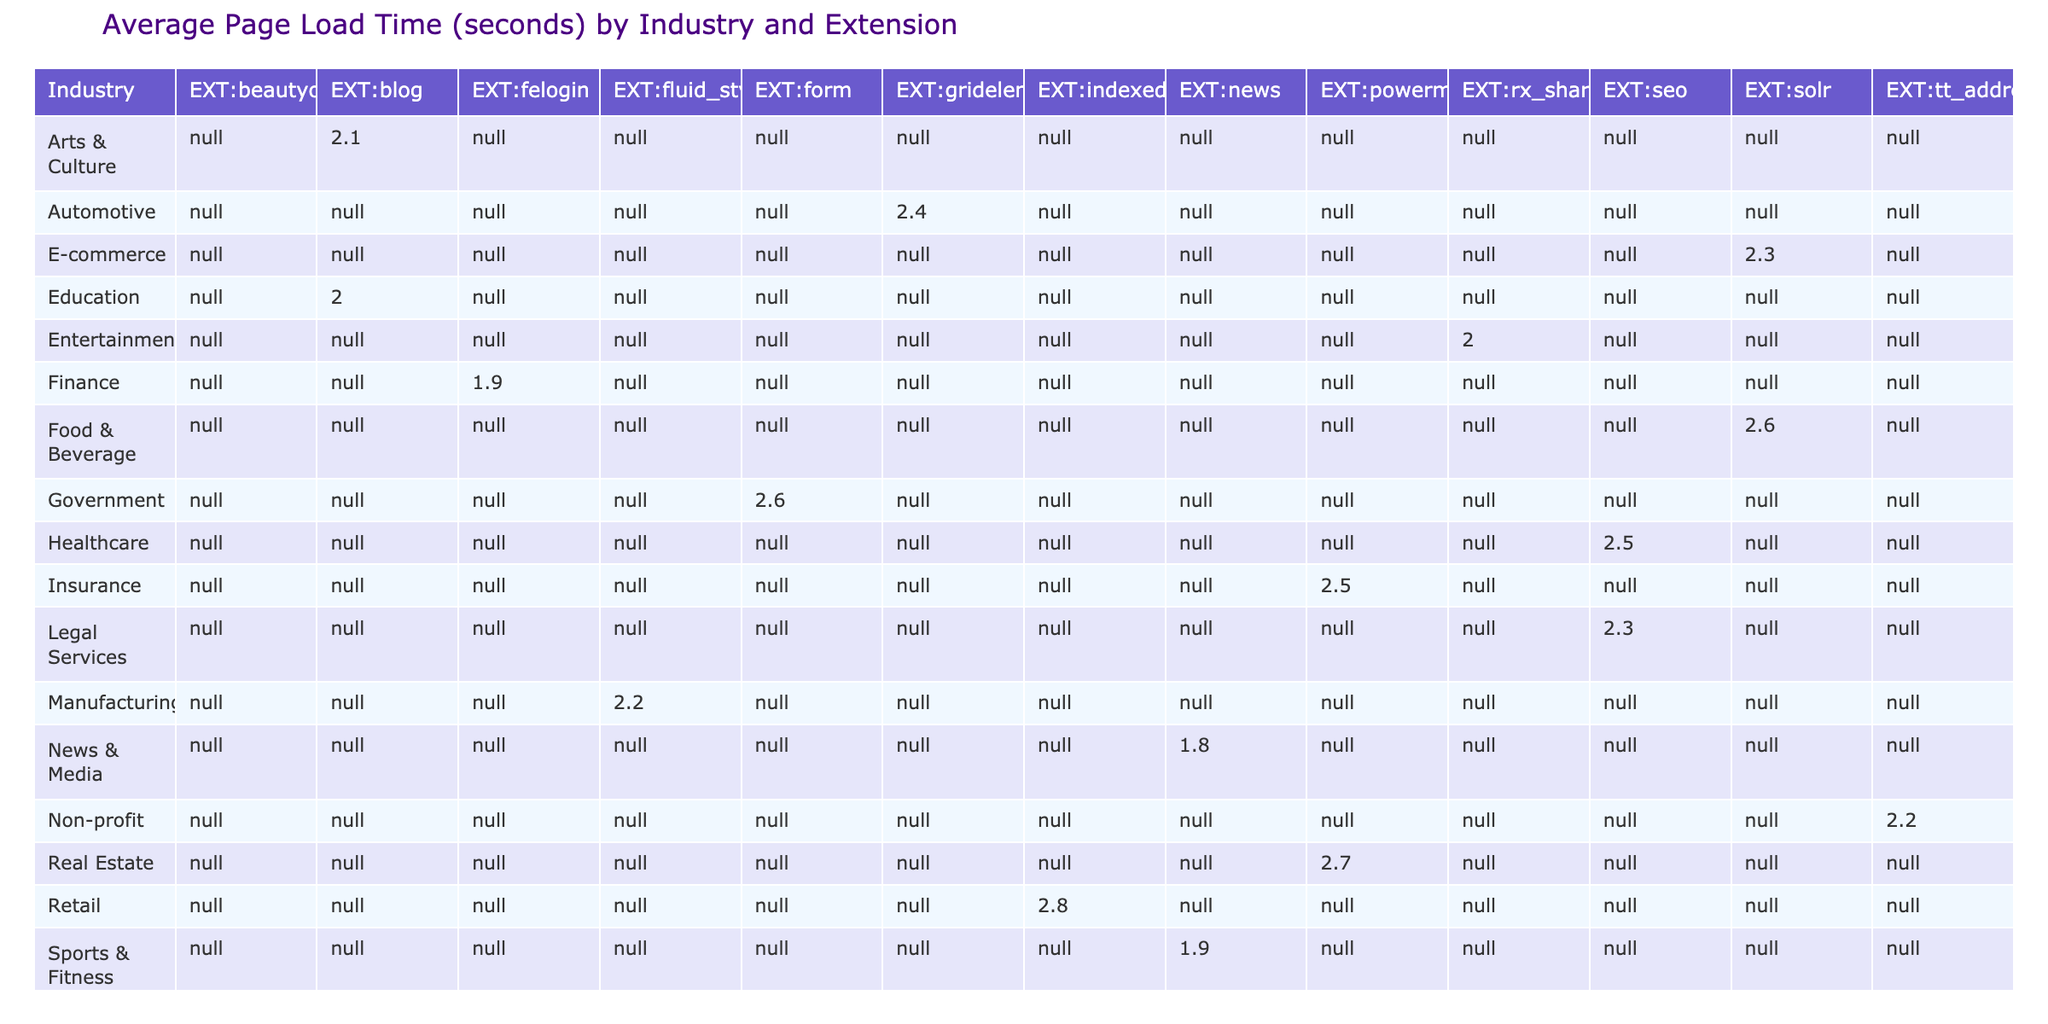What is the average page load time for the E-commerce industry using the solr extension? The table shows that the average page load time for the solr extension in the E-commerce industry is 2.3 seconds.
Answer: 2.3 seconds Which extension has the highest page load time in the Real Estate industry? In the Real Estate industry, the powermail extension has the highest page load time of 2.7 seconds compared to other listed extensions.
Answer: powermail Is the average page load time for the Healthcare industry greater than 2.4 seconds? The extension seo for the Healthcare industry shows a page load time of 2.5 seconds, which confirms that it is greater than 2.4 seconds.
Answer: Yes What is the average page load time for the Technology and Telecommunications industries combined? The average for Technology (1.7) and Telecommunications (2.4) is calculated as (1.7 + 2.4) / 2 = 2.05 seconds.
Answer: 2.05 seconds Does the Non-profit industry have a lower page load time than the Finance industry? The table states that the Non-profit industry has a page load time of 2.2 seconds, while the Finance industry has a page load time of 1.9 seconds. Since 2.2 is greater than 1.9, the Non-profit industry does not have a lower page load time.
Answer: No Which industries have an average page load time below 2.2 seconds? By filtering through the table, we can see that the Technology industry (1.7) and the Finance industry (1.9) have an average page load time below 2.2 seconds.
Answer: Technology, Finance What is the total page load time for all extensions in the Manufacturing industry? The table indicates the fluid_styled_content extension has a page load time of 2.2 seconds in the Manufacturing industry. Therefore, the total page load time is 2.2 seconds since it's the only extension listed for that industry.
Answer: 2.2 seconds What is the difference in page load time between the extension with the fastest and the one with the slowest load time in the Travel & Tourism industry? The rx_shariff extension has a page load time of 2.1 seconds, and since it is the only extension listed for Travel & Tourism, we can conclude that the fastest (2.1) and slowest (2.1) load times are the same, leading to a difference of 0 seconds.
Answer: 0 seconds Which industry has a conversion rate above 4% among the listed extensions? Looking at the table, the Technology industry has the beautyofcode extension with a conversion rate of 4.5%, which is above 4%. Additionally, the Real Estate industry (powermail) has a conversion rate of 4.2%, also above 4%.
Answer: Technology, Real Estate 